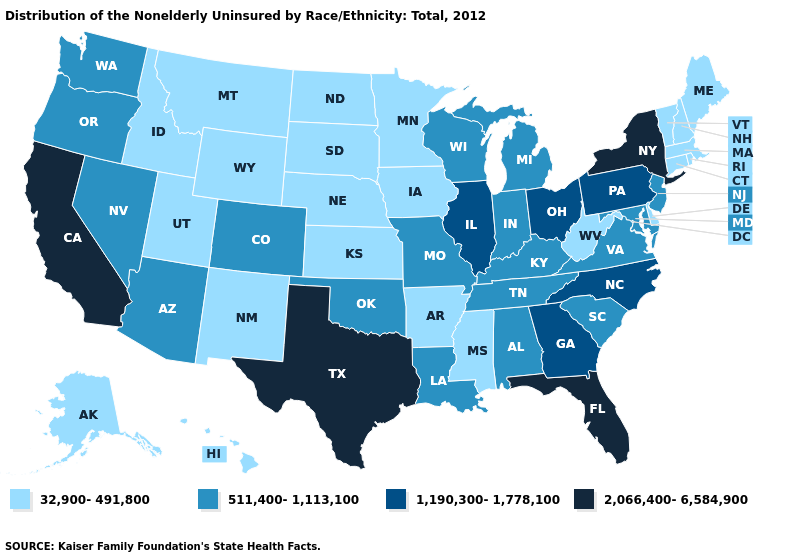Does Missouri have a higher value than Tennessee?
Quick response, please. No. Is the legend a continuous bar?
Be succinct. No. Name the states that have a value in the range 32,900-491,800?
Quick response, please. Alaska, Arkansas, Connecticut, Delaware, Hawaii, Idaho, Iowa, Kansas, Maine, Massachusetts, Minnesota, Mississippi, Montana, Nebraska, New Hampshire, New Mexico, North Dakota, Rhode Island, South Dakota, Utah, Vermont, West Virginia, Wyoming. What is the value of South Carolina?
Write a very short answer. 511,400-1,113,100. What is the value of Ohio?
Quick response, please. 1,190,300-1,778,100. Which states have the highest value in the USA?
Short answer required. California, Florida, New York, Texas. Name the states that have a value in the range 1,190,300-1,778,100?
Be succinct. Georgia, Illinois, North Carolina, Ohio, Pennsylvania. Does the map have missing data?
Keep it brief. No. What is the lowest value in the South?
Short answer required. 32,900-491,800. What is the lowest value in the USA?
Quick response, please. 32,900-491,800. What is the value of Minnesota?
Answer briefly. 32,900-491,800. What is the highest value in the USA?
Keep it brief. 2,066,400-6,584,900. What is the value of West Virginia?
Keep it brief. 32,900-491,800. Name the states that have a value in the range 1,190,300-1,778,100?
Write a very short answer. Georgia, Illinois, North Carolina, Ohio, Pennsylvania. What is the lowest value in states that border Illinois?
Be succinct. 32,900-491,800. 